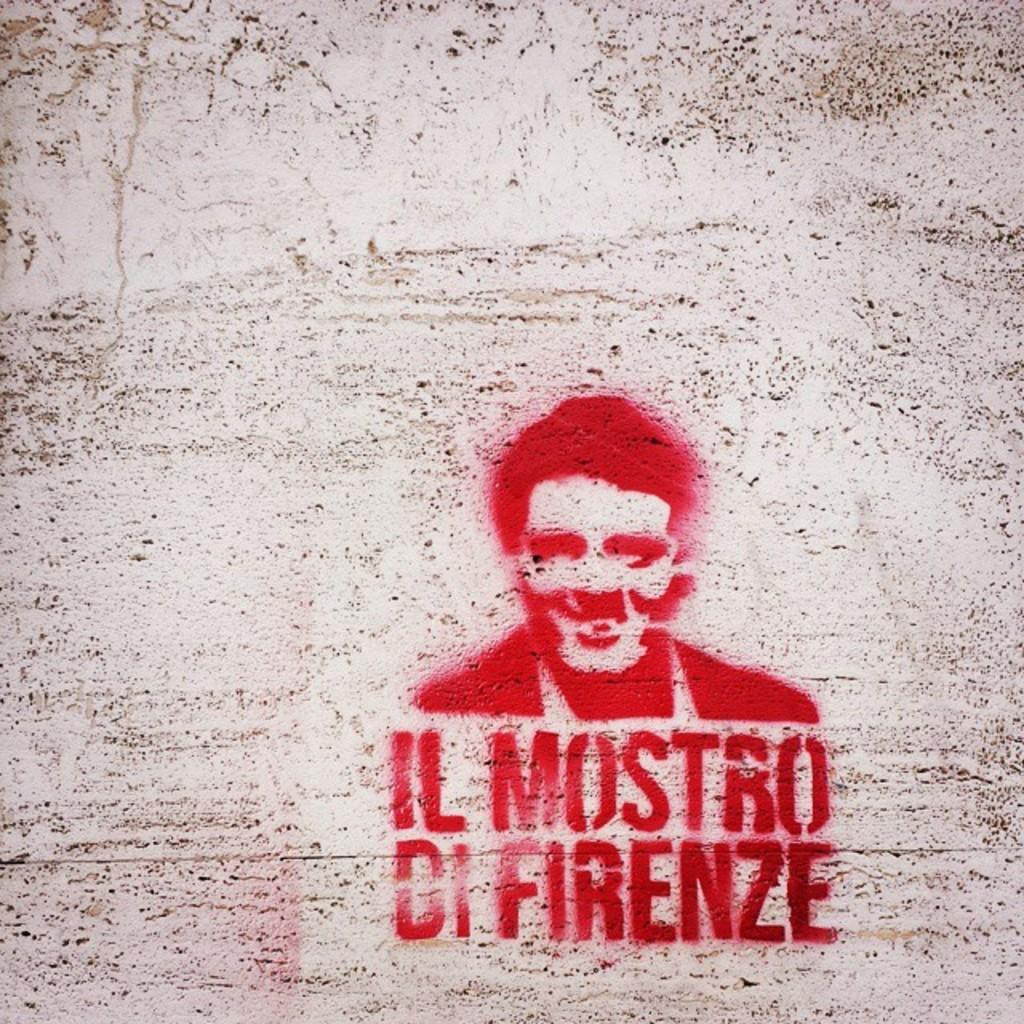What is on the wall in the image? There is a painting on the wall in the image. What is depicted on the painting? The painting has text written on it. How many rabbits can be seen playing in the orange snow during winter in the image? There are no rabbits, orange snow, or winter depicted in the image; it features a painting with text on it. 